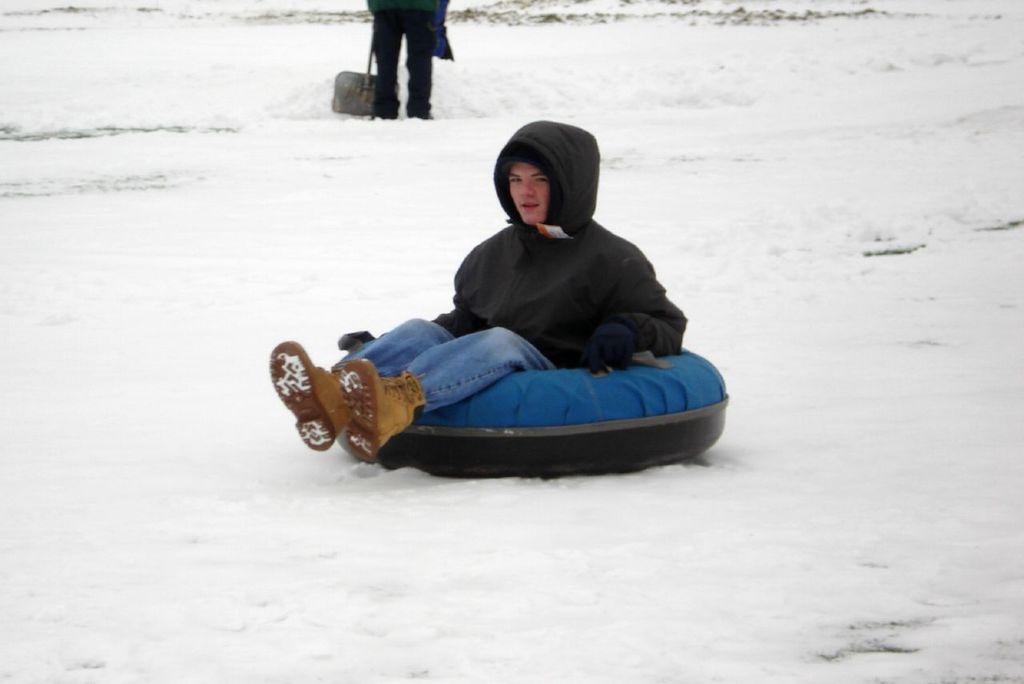In one or two sentences, can you explain what this image depicts? In this image, we can see a person wearing clothes and sitting on the tube. There is an another person who´is face is not visible standing at the top of the image. 